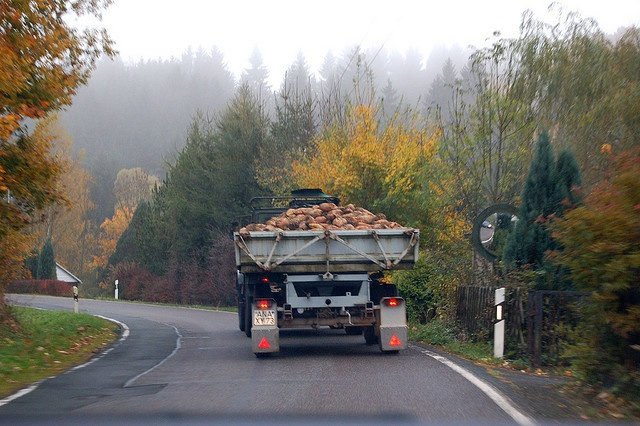Describe the objects in this image and their specific colors. I can see a truck in brown, black, gray, and darkgray tones in this image. 